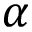<formula> <loc_0><loc_0><loc_500><loc_500>\alpha</formula> 